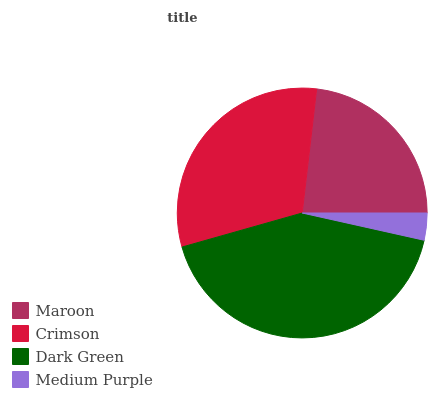Is Medium Purple the minimum?
Answer yes or no. Yes. Is Dark Green the maximum?
Answer yes or no. Yes. Is Crimson the minimum?
Answer yes or no. No. Is Crimson the maximum?
Answer yes or no. No. Is Crimson greater than Maroon?
Answer yes or no. Yes. Is Maroon less than Crimson?
Answer yes or no. Yes. Is Maroon greater than Crimson?
Answer yes or no. No. Is Crimson less than Maroon?
Answer yes or no. No. Is Crimson the high median?
Answer yes or no. Yes. Is Maroon the low median?
Answer yes or no. Yes. Is Medium Purple the high median?
Answer yes or no. No. Is Medium Purple the low median?
Answer yes or no. No. 